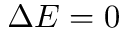<formula> <loc_0><loc_0><loc_500><loc_500>\Delta E = 0</formula> 